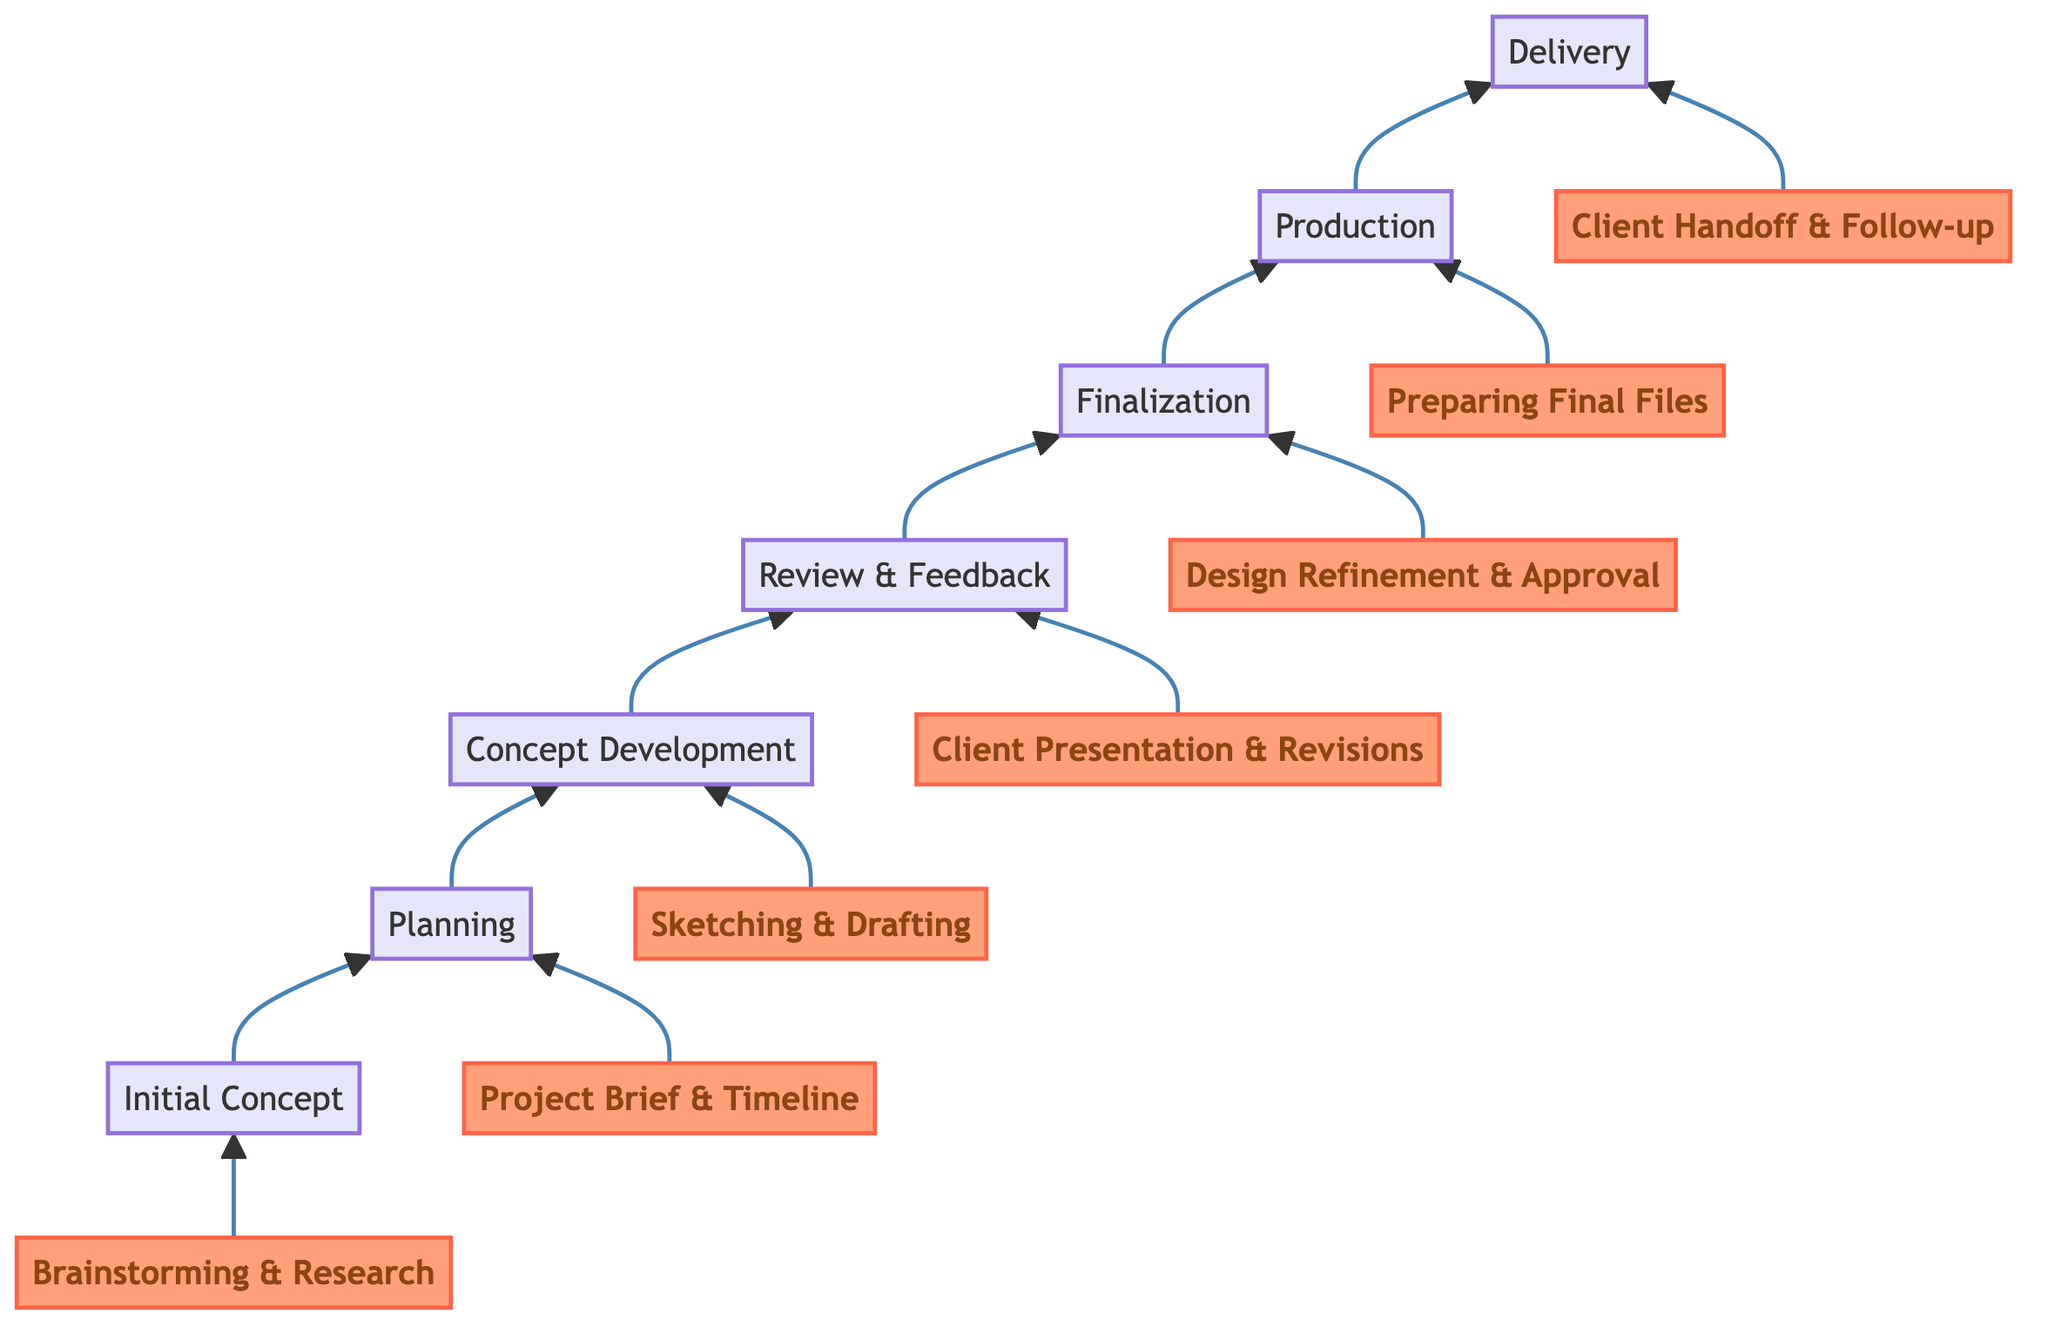What is the first step in the workflow? The diagram indicates that the first step is "Initial Concept," which is positioned at the bottom of the flow chart, signifying its starting point in the project workflow.
Answer: Initial Concept How many milestones are present in the diagram? The diagram includes seven milestones, each labeled and situated between the various steps in the workflow, culminating in the final milestone "Client Handoff & Follow-up."
Answer: Seven What milestone follows "Concept Development"? From the diagram, it shows an arrow pointing upward from "Concept Development," leading directly to the next milestone, which is "Review & Feedback."
Answer: Review & Feedback What is the last step in the workflow? The flow chart displays the last step at the top as "Delivery," which signifies the final phase of the graphic design project workflow.
Answer: Delivery Which step involves gathering client feedback? The diagram connects "Review & Feedback" with tasks focused on client presentations and gathering feedback, highlighting its role in this part of the workflow.
Answer: Review & Feedback What is the main task in the "Finalization" milestone? Looking at the flow chart, the task details include adjusting typography, color schemes, and obtaining client approval, which define the focus of the "Finalization" milestone.
Answer: Design Refinement & Approval What step comes before "Production"? The diagram indicates that "Finalization" leads directly into "Production," hence "Finalization" is the step before "Production."
Answer: Finalization Which milestone focuses on preparing all necessary files for delivery? In the diagram, "Production" specifically emphasizes preparing final files, which entails exporting different formats for the project delivery.
Answer: Preparing Final Files 